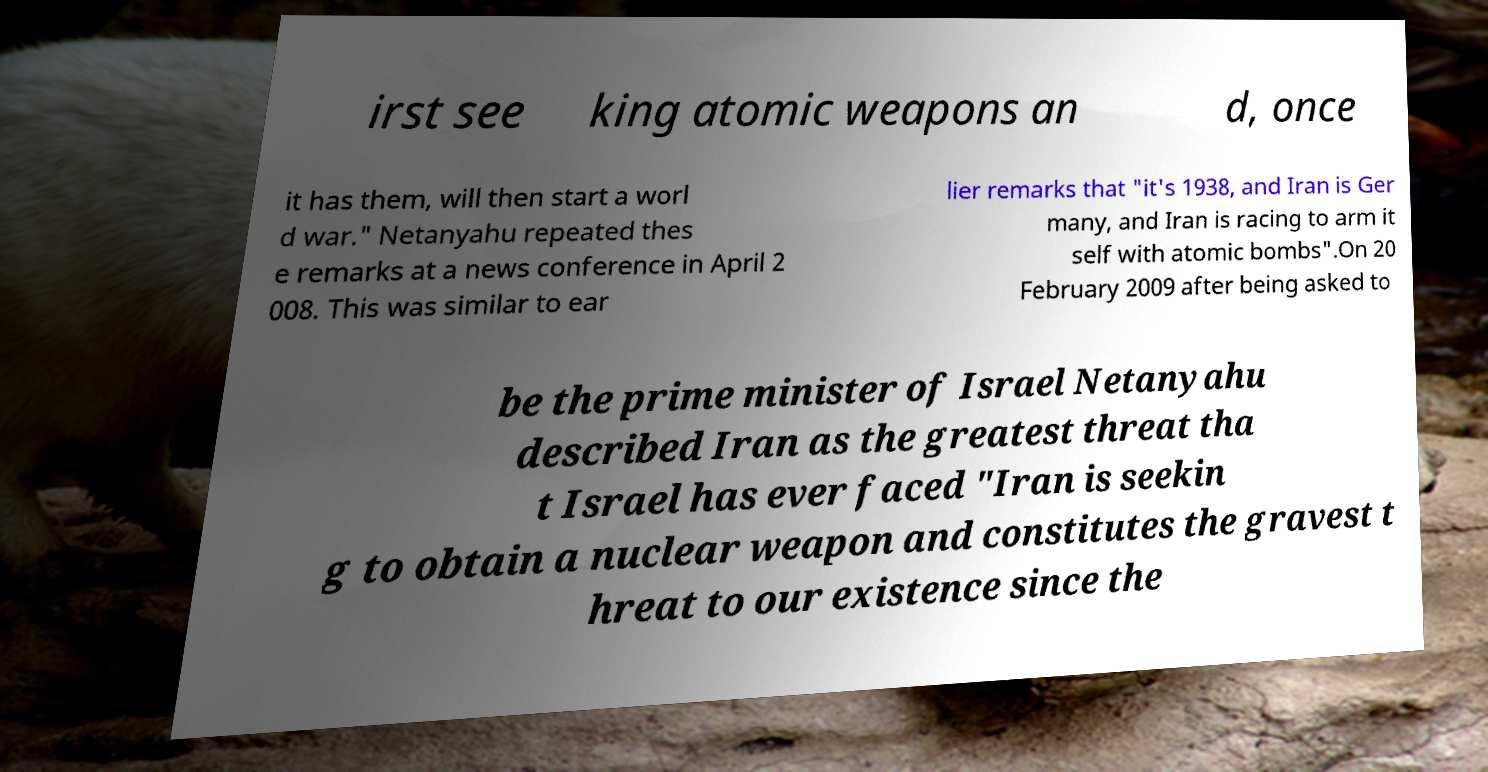Could you assist in decoding the text presented in this image and type it out clearly? irst see king atomic weapons an d, once it has them, will then start a worl d war." Netanyahu repeated thes e remarks at a news conference in April 2 008. This was similar to ear lier remarks that "it's 1938, and Iran is Ger many, and Iran is racing to arm it self with atomic bombs".On 20 February 2009 after being asked to be the prime minister of Israel Netanyahu described Iran as the greatest threat tha t Israel has ever faced "Iran is seekin g to obtain a nuclear weapon and constitutes the gravest t hreat to our existence since the 